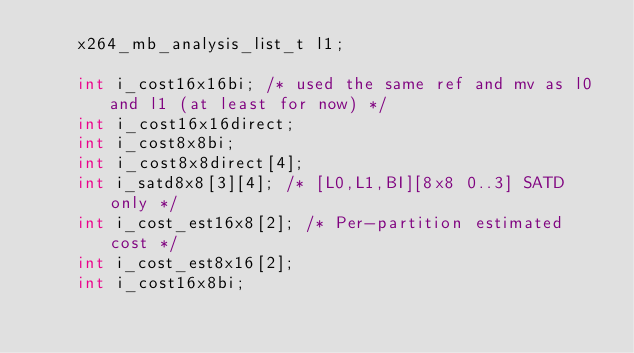Convert code to text. <code><loc_0><loc_0><loc_500><loc_500><_C_>    x264_mb_analysis_list_t l1;

    int i_cost16x16bi; /* used the same ref and mv as l0 and l1 (at least for now) */
    int i_cost16x16direct;
    int i_cost8x8bi;
    int i_cost8x8direct[4];
    int i_satd8x8[3][4]; /* [L0,L1,BI][8x8 0..3] SATD only */
    int i_cost_est16x8[2]; /* Per-partition estimated cost */
    int i_cost_est8x16[2];
    int i_cost16x8bi;</code> 